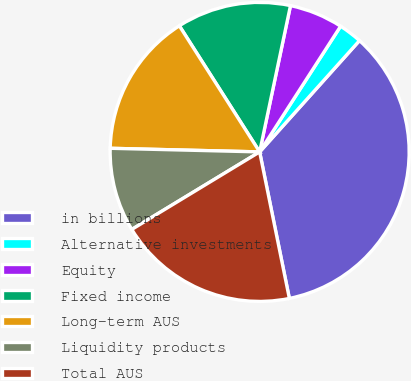<chart> <loc_0><loc_0><loc_500><loc_500><pie_chart><fcel>in billions<fcel>Alternative investments<fcel>Equity<fcel>Fixed income<fcel>Long-term AUS<fcel>Liquidity products<fcel>Total AUS<nl><fcel>35.18%<fcel>2.53%<fcel>5.8%<fcel>12.33%<fcel>15.59%<fcel>9.06%<fcel>19.51%<nl></chart> 